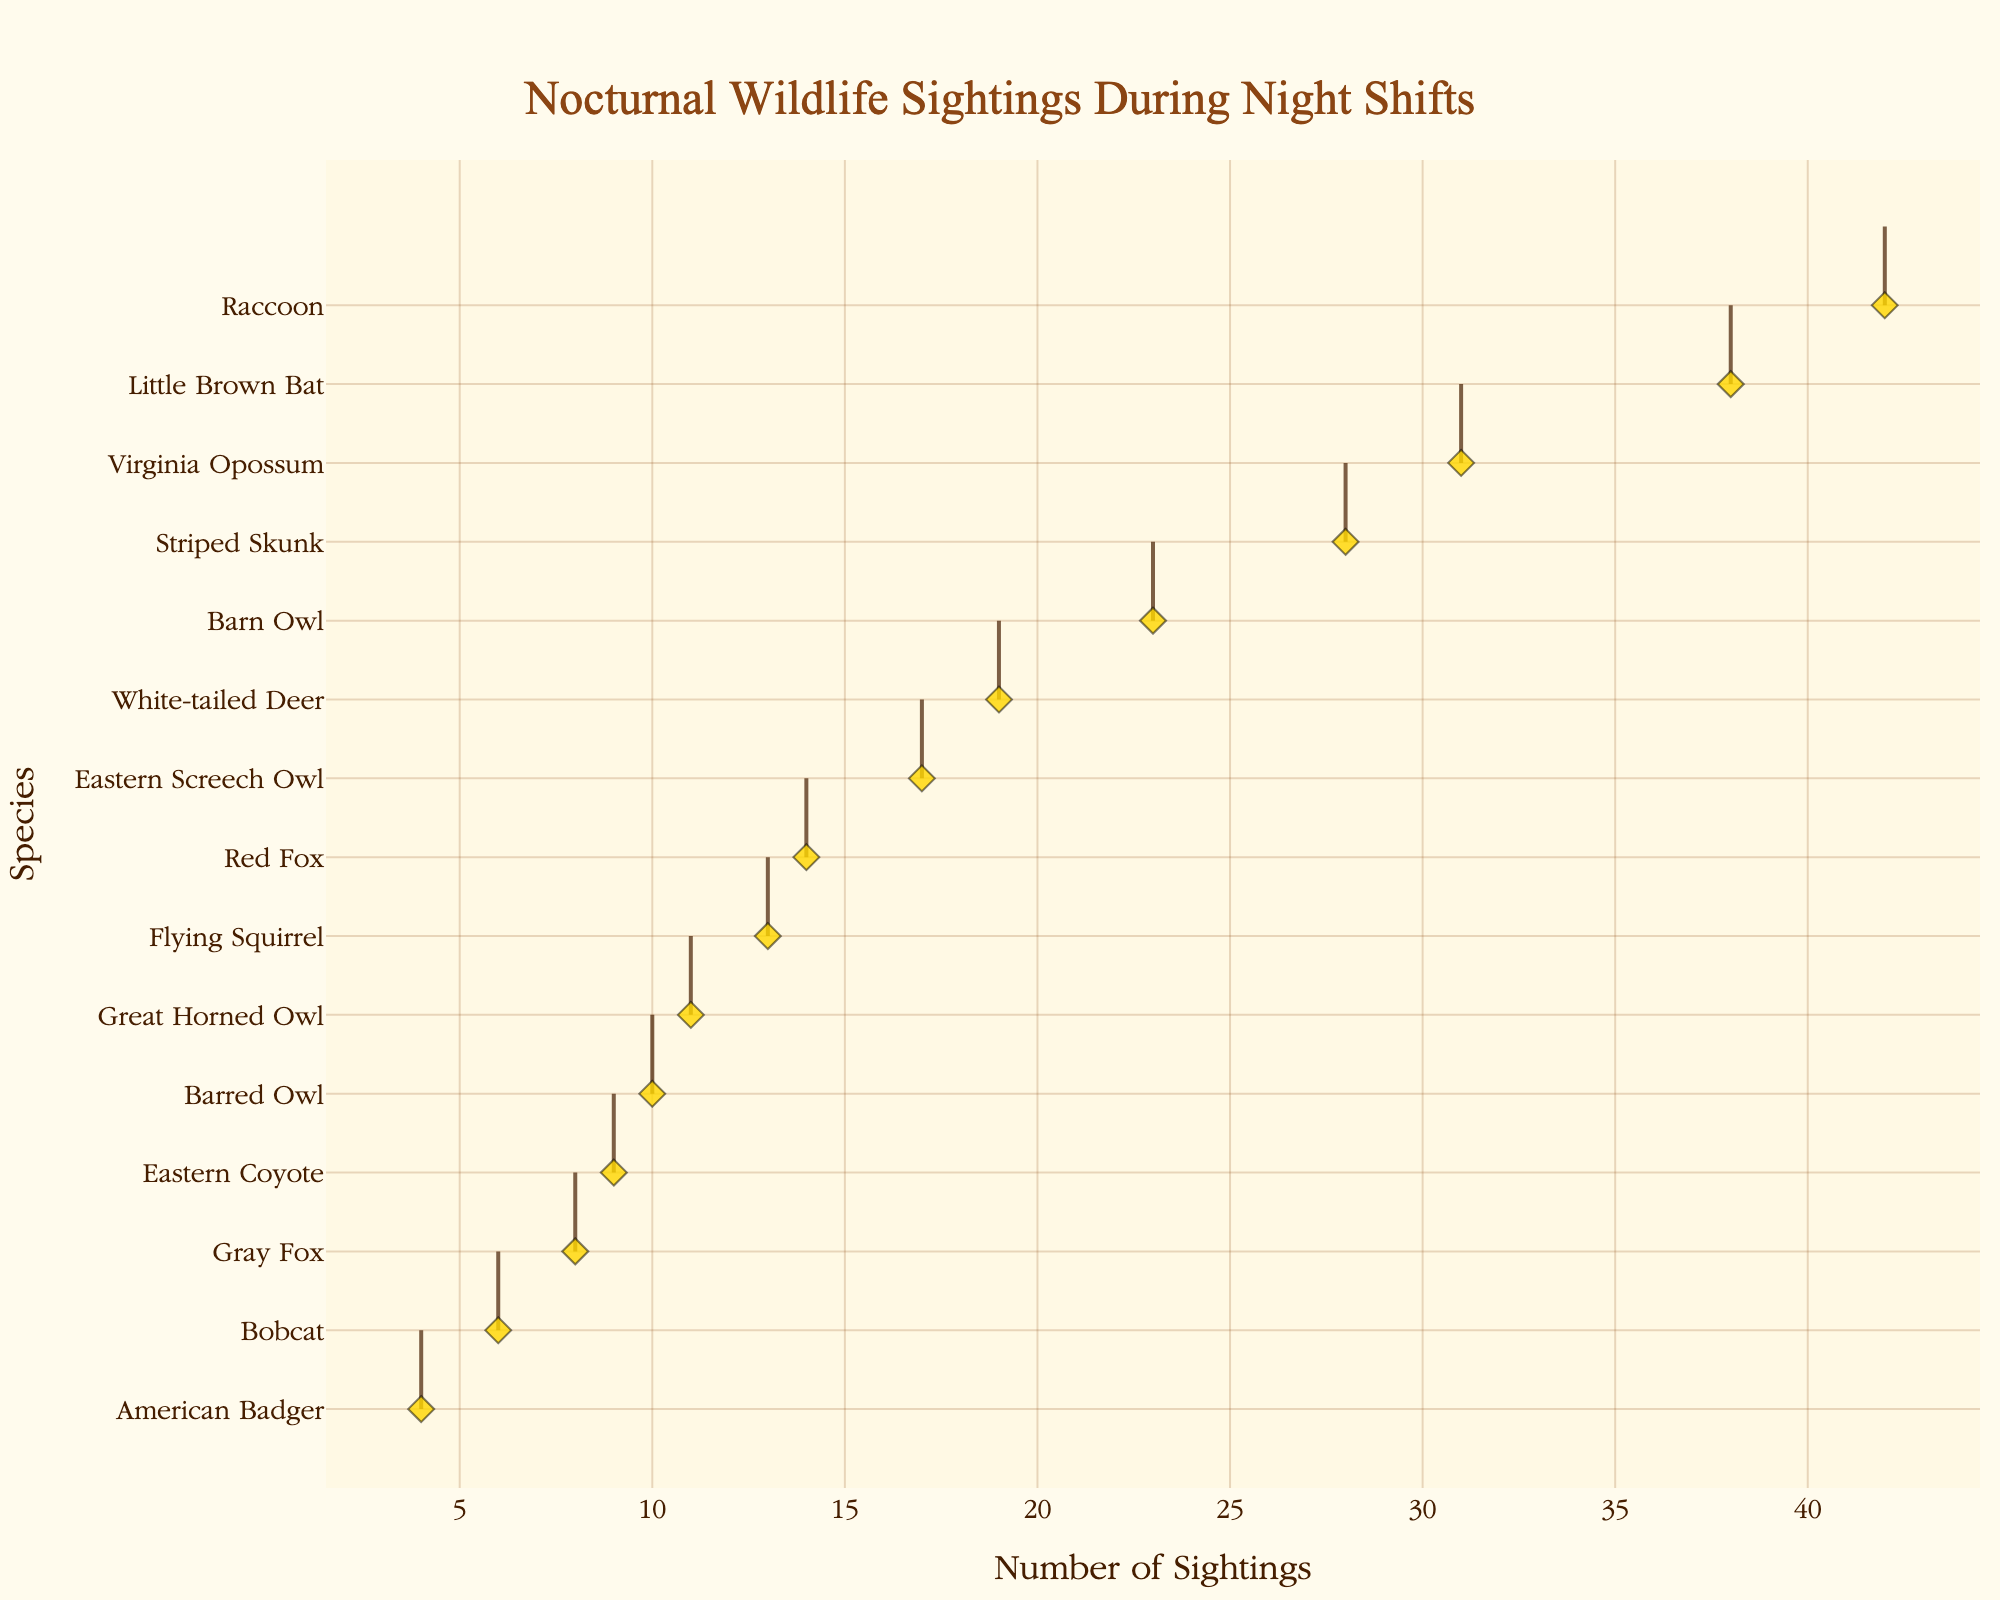what's the title of the figure? The title of the figure is located at the top and is usually the most prominent text. In this figure, it is styled in a particular font and color.
Answer: Nocturnal Wildlife Sightings During Night Shifts How many species have sightings greater than 20? Count the number of species from the figure where the sighting values exceed 20.
Answer: 4 Which species has the highest number of sightings? Examine the density plot and find the species whose peak is the farthest to the right.
Answer: Raccoon What is the average number of sightings for the three owl species (Barn Owl, Eastern Screech Owl, Great Horned Owl)? Find the number of sightings for each owl species and calculate their average. Barn Owl (23), Eastern Screech Owl (17), and Great Horned Owl (11). (23 + 17 + 11) / 3 = 51 / 3 = 17
Answer: 17 Which species has the lowest number of sightings? Check the figure for the species positioned at the far left on the density plot.
Answer: American Badger What is the color of the scatter plot markers? Identify the color of the diamond-shaped markers used for actual sightings in the figure.
Answer: Gold How many species have sightings between 10 and 20? Count the species whose sighting values fall within the range of 10 to 20.
Answer: 5 Are there more nocturnal species with fewer than or greater than 15 sightings? Count how many species have fewer than 15 sightings versus how many have more than 15 sightings. Fewer than 15 (8 species: American Badger, Bobcat, Eastern Coyote, Gray Fox, Barred Owl, Red Fox, Flying Squirrel, and Great Horned Owl), Greater than 15 (7 species: Eastern Screech Owl, Barn Owl, White-tailed Deer, Striped Skunk, Little Brown Bat, Virginia Opossum, and Raccoon).
Answer: Fewer than 15 Which species have exactly 9 sightings? Look for the species where the sighting number is exactly 9.
Answer: Eastern Coyote What is the sighting difference between the species with the most and the least sightings? Subtract the lowest number of sightings (American Badger - 4) from the highest number of sightings (Raccoon - 42). 42 - 4 = 38
Answer: 38 